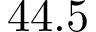<formula> <loc_0><loc_0><loc_500><loc_500>4 4 . 5</formula> 